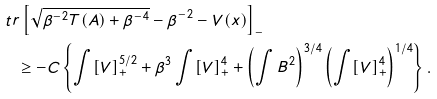Convert formula to latex. <formula><loc_0><loc_0><loc_500><loc_500>& \ t r \left [ \sqrt { \beta ^ { - 2 } T ( A ) + \beta ^ { - 4 } } - \beta ^ { - 2 } - V ( x ) \right ] _ { - } \\ & \quad \geq - C \left \{ \int [ V ] _ { + } ^ { 5 / 2 } + \beta ^ { 3 } \int [ V ] _ { + } ^ { 4 } + \left ( \int B ^ { 2 } \right ) ^ { 3 / 4 } \left ( \int [ V ] _ { + } ^ { 4 } \right ) ^ { 1 / 4 } \right \} .</formula> 